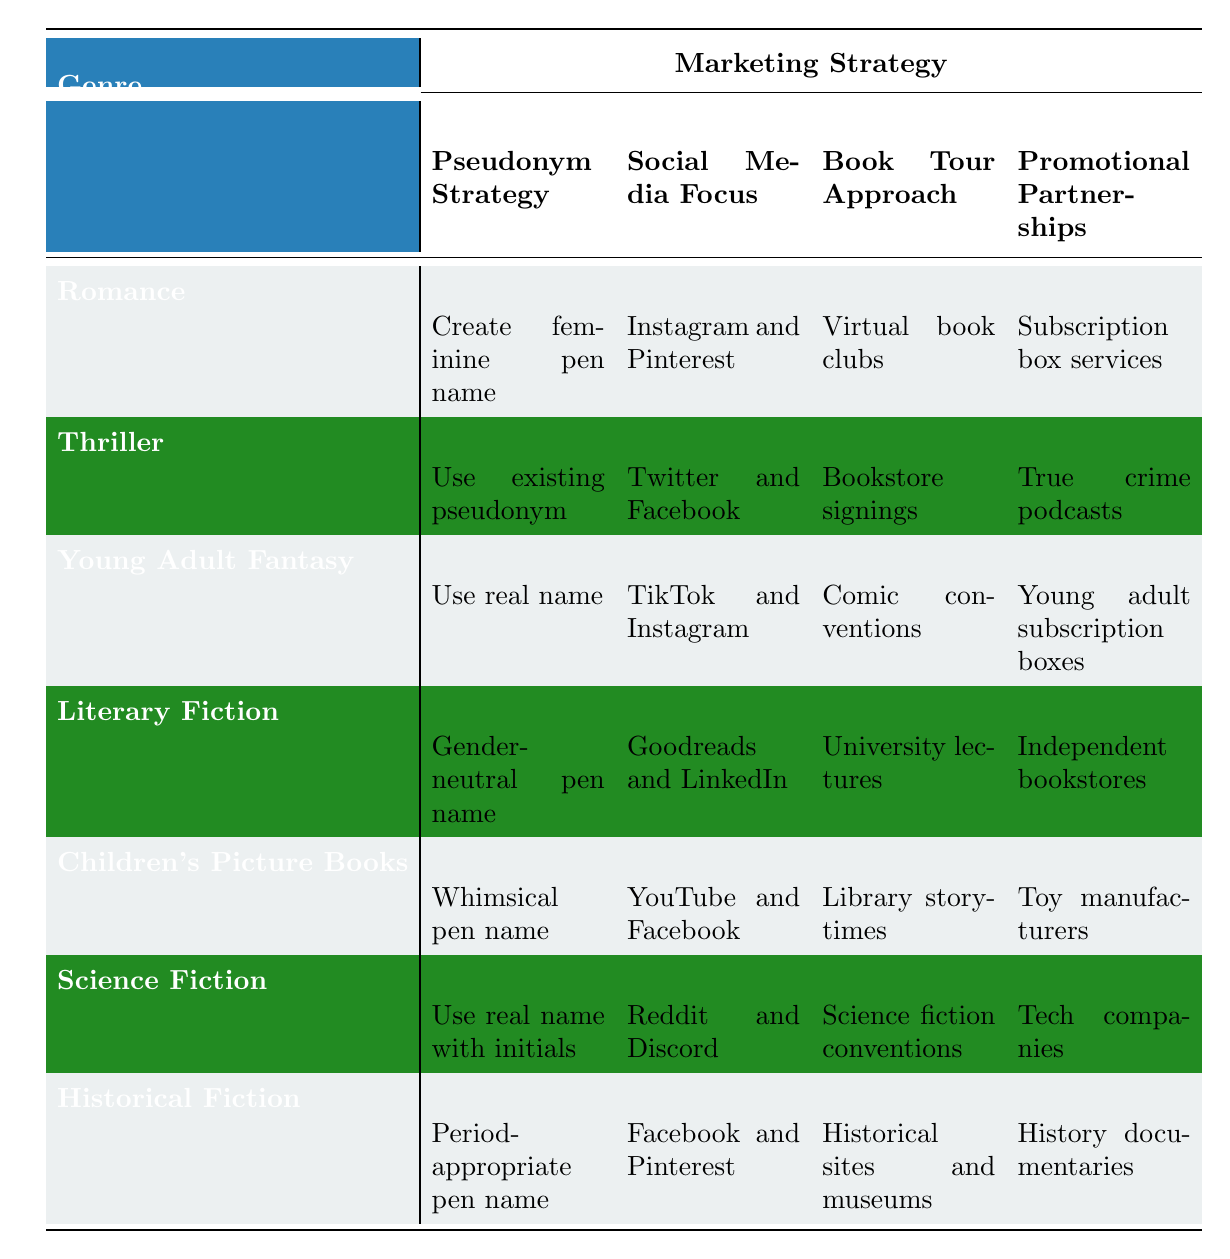What pseudonym strategy is recommended for historical fiction authors? The table indicates that for historical fiction, the recommended pseudonym strategy is to use a period-appropriate pen name. This is directly taken from the corresponding row for the genre.
Answer: Period-appropriate pen name Which social media platforms should thriller authors focus on? The table shows that thriller authors are recommended to focus on Twitter and Facebook, as noted in the table under the Thriller row.
Answer: Twitter and Facebook Is a whimsical pen name suggested for children's picture book authors? According to the table, a whimsical pen name is specifically recommended for children's picture book authors, as seen in the children's picture books row.
Answer: Yes What is the book tour approach suggested for romance authors? The table specifies that romance authors should use a virtual book club approach for their book tours, as outlined in the Romance row.
Answer: Virtual book clubs How many marketing strategies are listed for literary fiction compared to young adult fantasy? For literary fiction, there are four marketing strategies listed: gender-neutral pen name, Goodreads and LinkedIn, university lectures, and independent bookstores. For young adult fantasy, there are also four strategies listed: use real name, TikTok and Instagram, comic conventions, and young adult subscription boxes. Since both genres have four strategies, the answer is the same.
Answer: Four for each genre Do authors of science fiction and young adult fantasy have the same social media focus? The table indicates that science fiction authors should focus on Reddit and Discord, while young adult fantasy authors should focus on TikTok and Instagram. Since the social media platforms differ, the answer is no.
Answer: No What type of promotional partnerships should a debut science fiction author consider? The table states that for a debut science fiction author, the recommended promotional partnerships involve tech companies. This is found in the Science Fiction row of the table.
Answer: Tech companies Which author genre has the highest target audience demographic age range, and what is that range? The table shows that the target audience for thriller authors is adults aged 30-60, which is the largest demographic age range compared to other genres. This can be confirmed by examining the age range listed for each target audience.
Answer: Adults 30-60 What marketing strategy is unique to young adult fantasy authors? The table indicates that young adult fantasy authors are suggested to use their real name as a pseudonym strategy, which is distinct from other genres that utilize various types of pen names.
Answer: Use real name 